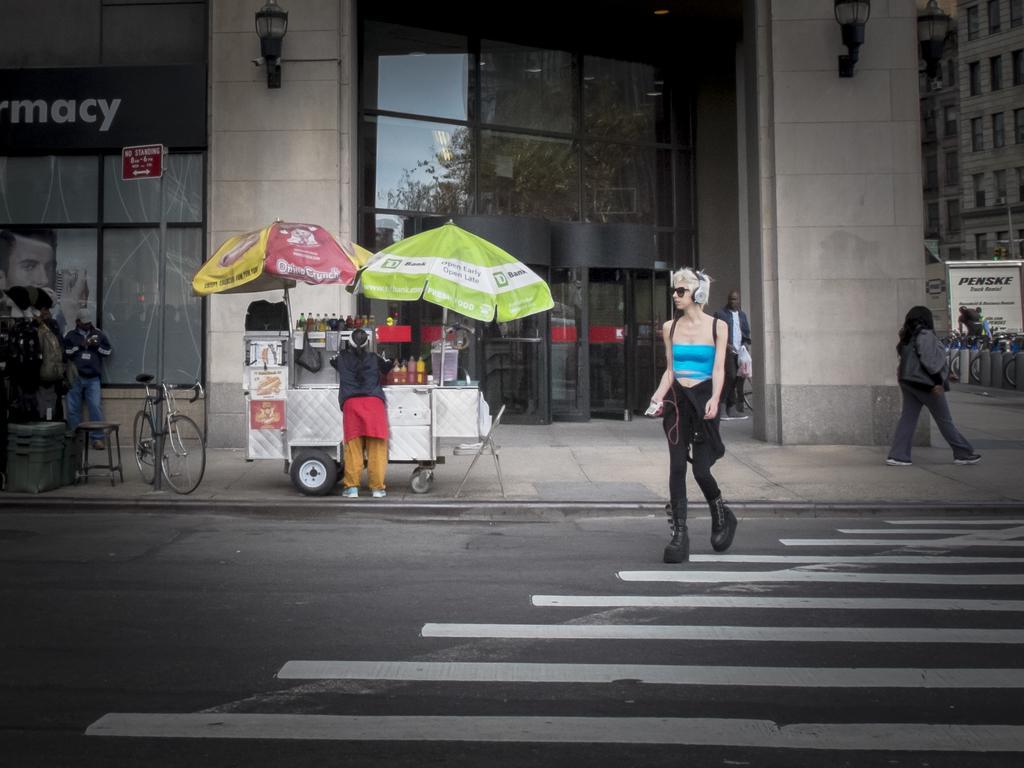Please provide a concise description of this image. Here we can see few persons and this is a road. There are umbrellas, cart, bottles, bicycle, chair, board, pole, lights, clothes, and a hoarding. In the background we can see buildings. 